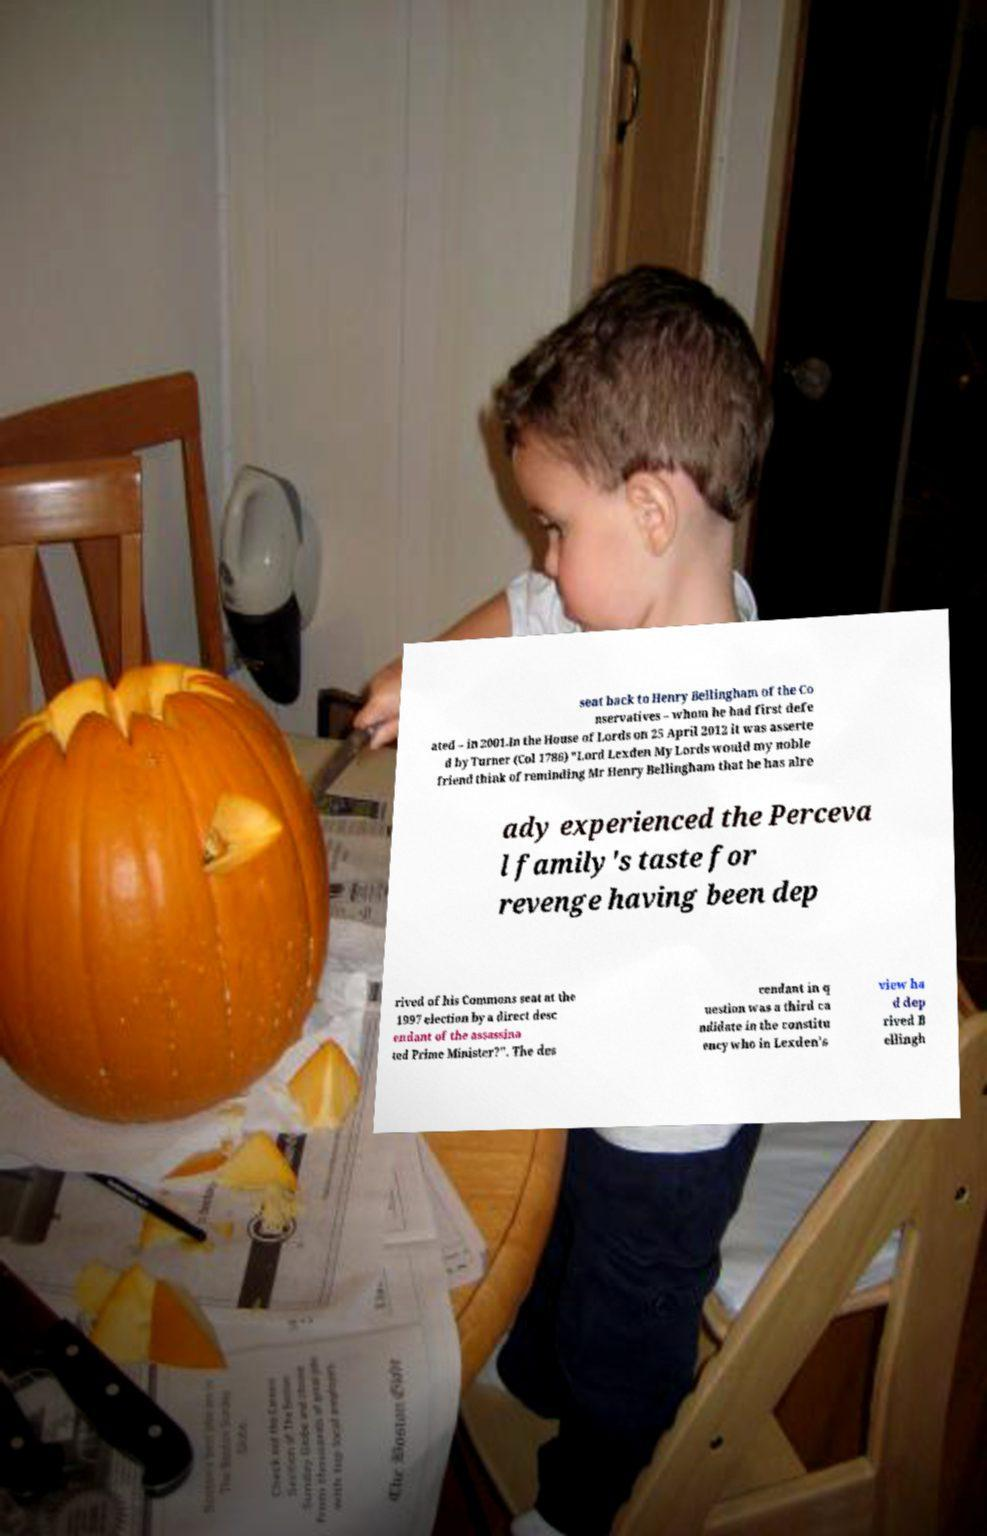For documentation purposes, I need the text within this image transcribed. Could you provide that? seat back to Henry Bellingham of the Co nservatives – whom he had first defe ated – in 2001.In the House of Lords on 25 April 2012 it was asserte d by Turner (Col 1786) "Lord Lexden My Lords would my noble friend think of reminding Mr Henry Bellingham that he has alre ady experienced the Perceva l family's taste for revenge having been dep rived of his Commons seat at the 1997 election by a direct desc endant of the assassina ted Prime Minister?". The des cendant in q uestion was a third ca ndidate in the constitu ency who in Lexden's view ha d dep rived B ellingh 